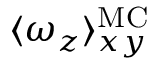<formula> <loc_0><loc_0><loc_500><loc_500>\langle \omega _ { z } \rangle _ { x y } ^ { M C }</formula> 